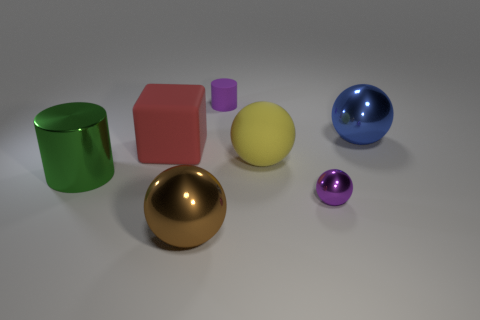What material is the cylinder on the right side of the thing to the left of the big red matte object? The cylinder on the right side of the object, to the left of the large red cube, appears to have a metallic finish, likely indicating that it's made of a type of metal rather than rubber. 